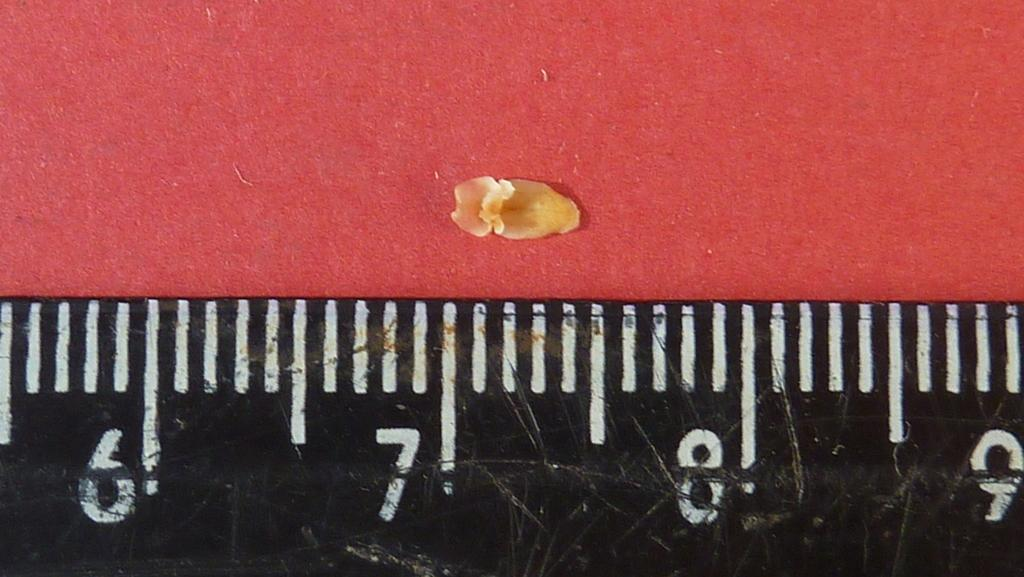<image>
Present a compact description of the photo's key features. a ruler with numbers 6-9 measure a yellow kernal 